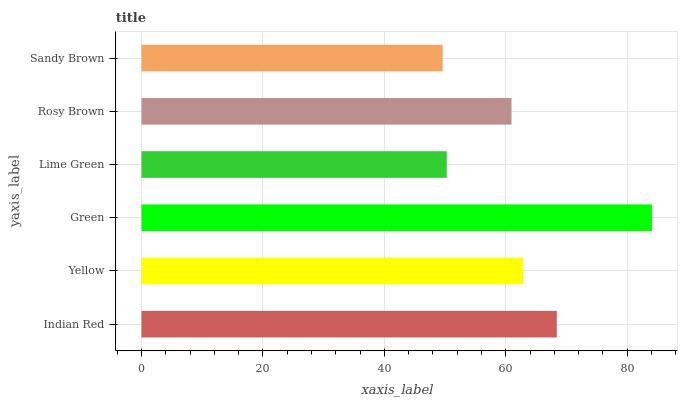Is Sandy Brown the minimum?
Answer yes or no. Yes. Is Green the maximum?
Answer yes or no. Yes. Is Yellow the minimum?
Answer yes or no. No. Is Yellow the maximum?
Answer yes or no. No. Is Indian Red greater than Yellow?
Answer yes or no. Yes. Is Yellow less than Indian Red?
Answer yes or no. Yes. Is Yellow greater than Indian Red?
Answer yes or no. No. Is Indian Red less than Yellow?
Answer yes or no. No. Is Yellow the high median?
Answer yes or no. Yes. Is Rosy Brown the low median?
Answer yes or no. Yes. Is Lime Green the high median?
Answer yes or no. No. Is Lime Green the low median?
Answer yes or no. No. 